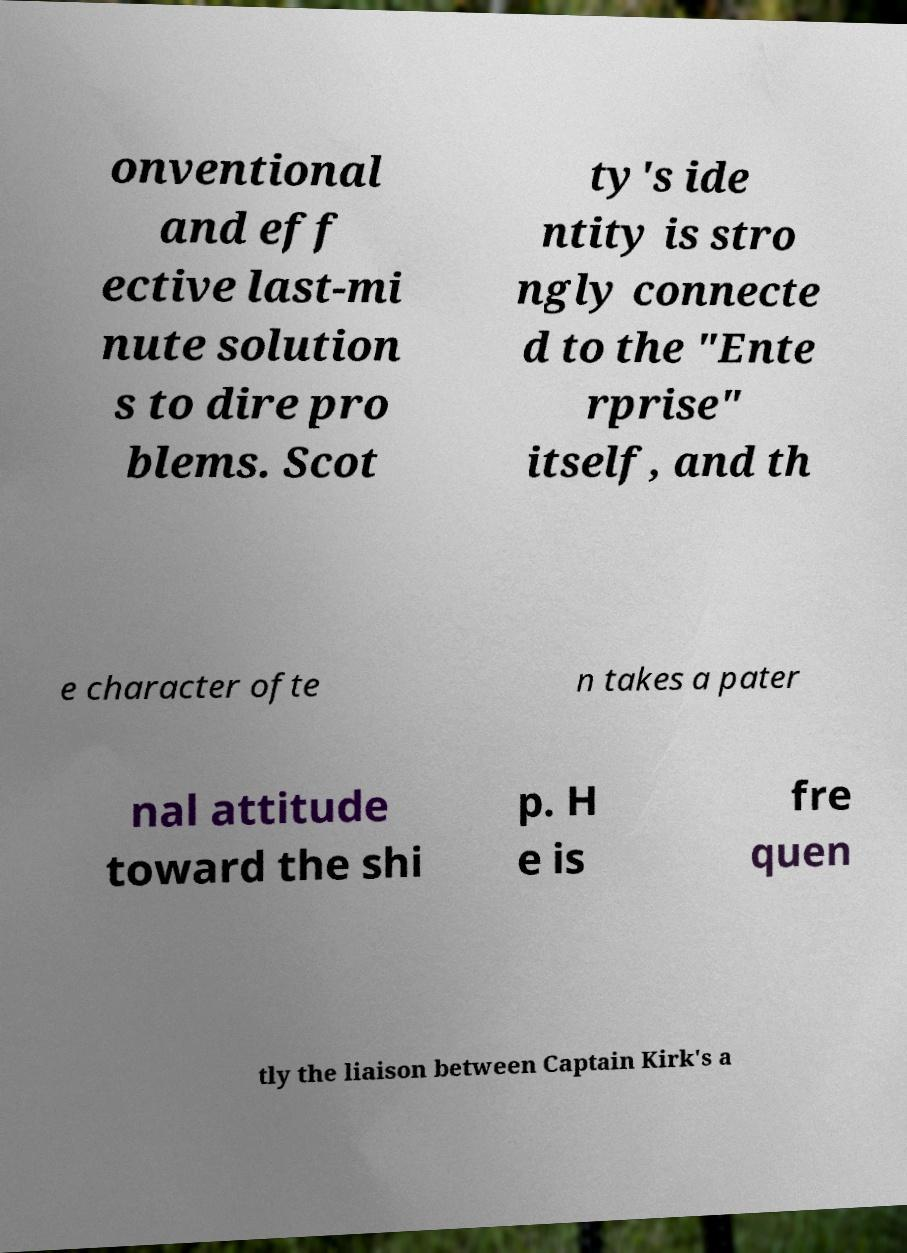Please identify and transcribe the text found in this image. onventional and eff ective last-mi nute solution s to dire pro blems. Scot ty's ide ntity is stro ngly connecte d to the "Ente rprise" itself, and th e character ofte n takes a pater nal attitude toward the shi p. H e is fre quen tly the liaison between Captain Kirk's a 